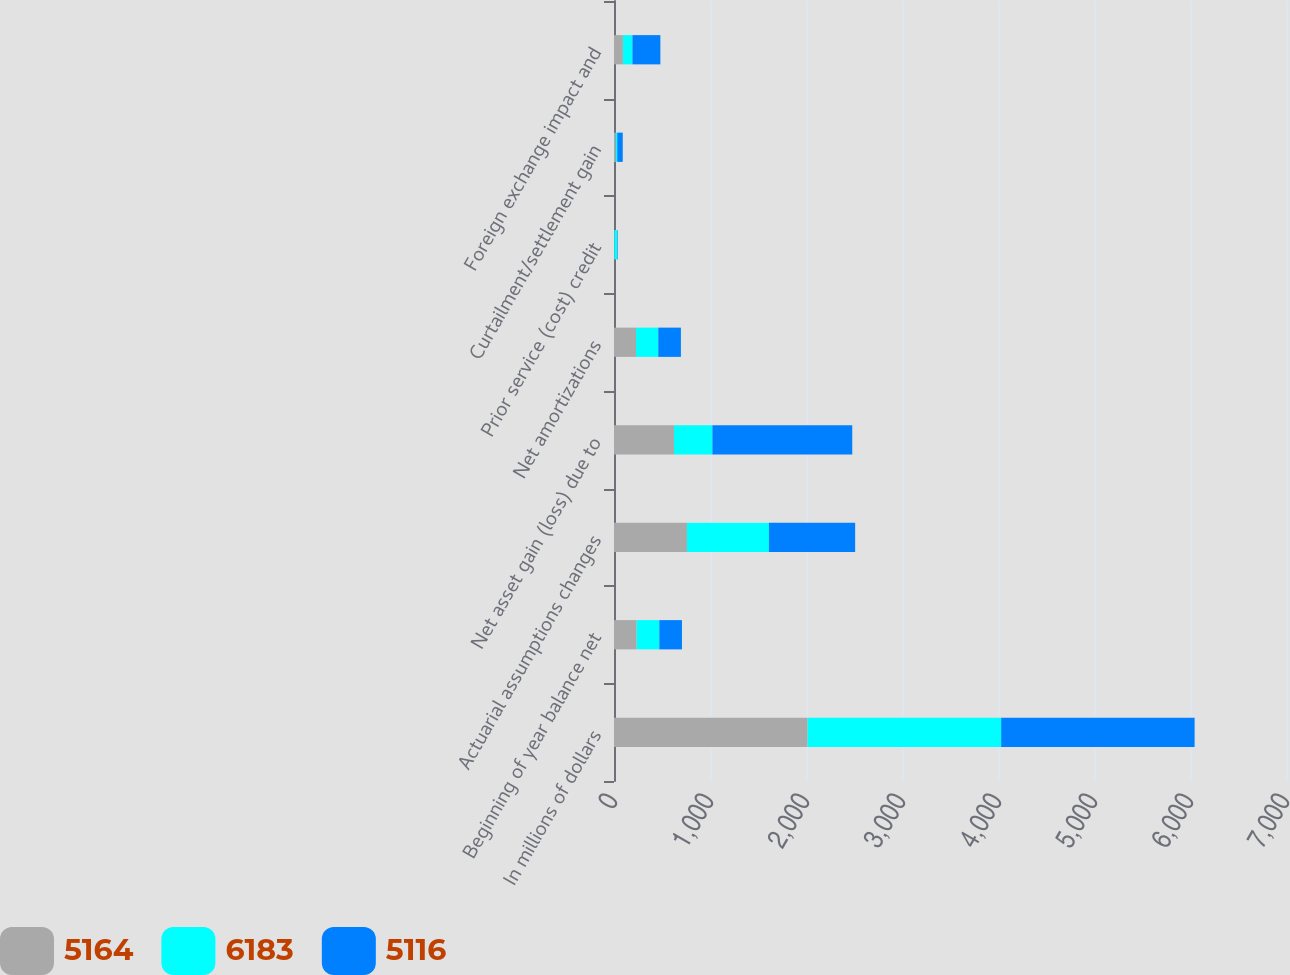Convert chart to OTSL. <chart><loc_0><loc_0><loc_500><loc_500><stacked_bar_chart><ecel><fcel>In millions of dollars<fcel>Beginning of year balance net<fcel>Actuarial assumptions changes<fcel>Net asset gain (loss) due to<fcel>Net amortizations<fcel>Prior service (cost) credit<fcel>Curtailment/settlement gain<fcel>Foreign exchange impact and<nl><fcel>5164<fcel>2017<fcel>236<fcel>760<fcel>625<fcel>229<fcel>4<fcel>17<fcel>93<nl><fcel>6183<fcel>2016<fcel>236<fcel>854<fcel>400<fcel>232<fcel>28<fcel>17<fcel>99<nl><fcel>5116<fcel>2015<fcel>236<fcel>898<fcel>1457<fcel>236<fcel>6<fcel>57<fcel>291<nl></chart> 